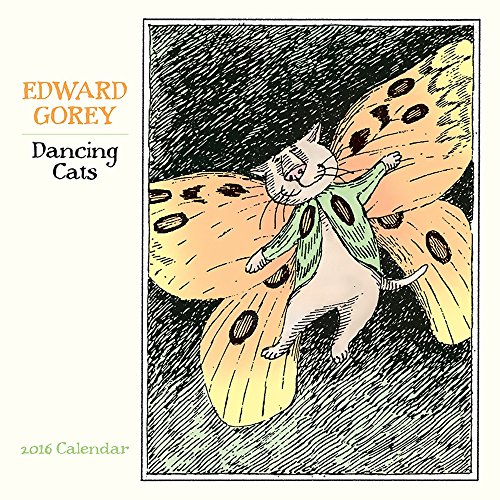What medium does it look like Edward Gorey used for these illustrations? Edward Gorey's work frequently featured pen and ink drawings. The intricate lines and cross-hatching suggest he may have used this medium for the 'Dancing Cats' illustrations as well. 